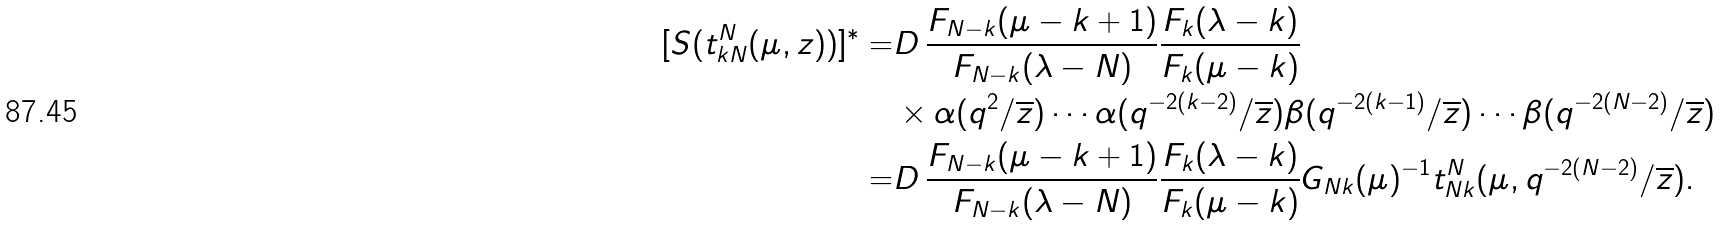<formula> <loc_0><loc_0><loc_500><loc_500>[ S ( t _ { k N } ^ { N } ( \mu , z ) ) ] ^ { * } = & D \, \frac { F _ { N - k } ( \mu - k + 1 ) } { F _ { N - k } ( \lambda - N ) } \frac { F _ { k } ( \lambda - k ) } { F _ { k } ( \mu - k ) } \\ & \times \alpha ( q ^ { 2 } / \overline { z } ) \cdots \alpha ( q ^ { - 2 ( k - 2 ) } / \overline { z } ) \beta ( q ^ { - 2 ( k - 1 ) } / \overline { z } ) \cdots \beta ( q ^ { - 2 ( N - 2 ) } / \overline { z } ) \\ = & D \, \frac { F _ { N - k } ( \mu - k + 1 ) } { F _ { N - k } ( \lambda - N ) } \frac { F _ { k } ( \lambda - k ) } { F _ { k } ( \mu - k ) } G _ { N k } ( \mu ) ^ { - 1 } t _ { N k } ^ { N } ( \mu , q ^ { - 2 ( N - 2 ) } / \overline { z } ) .</formula> 